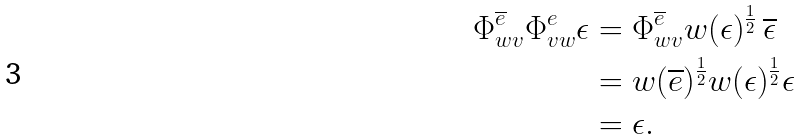<formula> <loc_0><loc_0><loc_500><loc_500>\Phi ^ { \overline { e } } _ { w v } \Phi ^ { e } _ { v w } \epsilon & = \Phi ^ { \overline { e } } _ { w v } w ( \epsilon ) ^ { \frac { 1 } { 2 } } \, \overline { \epsilon } \\ & = w ( \overline { e } ) ^ { \frac { 1 } { 2 } } w ( \epsilon ) ^ { \frac { 1 } { 2 } } \epsilon \\ & = \epsilon .</formula> 